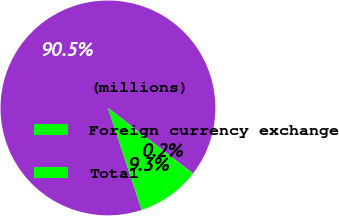Convert chart to OTSL. <chart><loc_0><loc_0><loc_500><loc_500><pie_chart><fcel>(millions)<fcel>Foreign currency exchange<fcel>Total<nl><fcel>90.52%<fcel>0.22%<fcel>9.25%<nl></chart> 